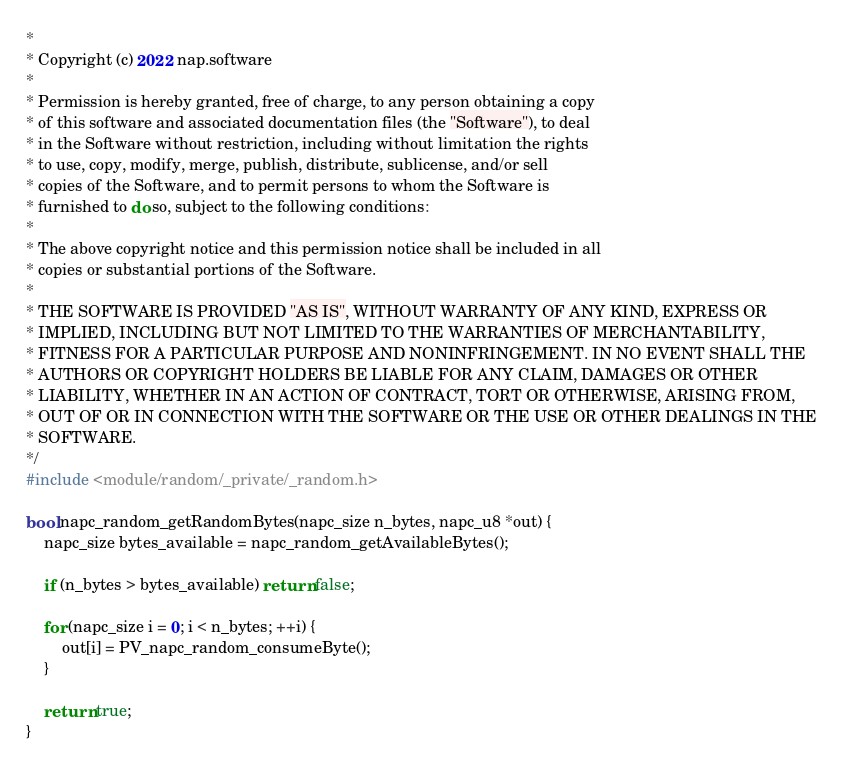<code> <loc_0><loc_0><loc_500><loc_500><_C_>* 
* Copyright (c) 2022 nap.software
* 
* Permission is hereby granted, free of charge, to any person obtaining a copy
* of this software and associated documentation files (the "Software"), to deal
* in the Software without restriction, including without limitation the rights
* to use, copy, modify, merge, publish, distribute, sublicense, and/or sell
* copies of the Software, and to permit persons to whom the Software is
* furnished to do so, subject to the following conditions:
* 
* The above copyright notice and this permission notice shall be included in all
* copies or substantial portions of the Software.
* 
* THE SOFTWARE IS PROVIDED "AS IS", WITHOUT WARRANTY OF ANY KIND, EXPRESS OR
* IMPLIED, INCLUDING BUT NOT LIMITED TO THE WARRANTIES OF MERCHANTABILITY,
* FITNESS FOR A PARTICULAR PURPOSE AND NONINFRINGEMENT. IN NO EVENT SHALL THE
* AUTHORS OR COPYRIGHT HOLDERS BE LIABLE FOR ANY CLAIM, DAMAGES OR OTHER
* LIABILITY, WHETHER IN AN ACTION OF CONTRACT, TORT OR OTHERWISE, ARISING FROM,
* OUT OF OR IN CONNECTION WITH THE SOFTWARE OR THE USE OR OTHER DEALINGS IN THE
* SOFTWARE.
*/
#include <module/random/_private/_random.h>

bool napc_random_getRandomBytes(napc_size n_bytes, napc_u8 *out) {
	napc_size bytes_available = napc_random_getAvailableBytes();

	if (n_bytes > bytes_available) return false;

	for (napc_size i = 0; i < n_bytes; ++i) {
		out[i] = PV_napc_random_consumeByte();
	}

	return true;
}
</code> 